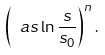<formula> <loc_0><loc_0><loc_500><loc_500>\left ( \ a s \ln \frac { s } { s _ { 0 } } \right ) ^ { n } .</formula> 